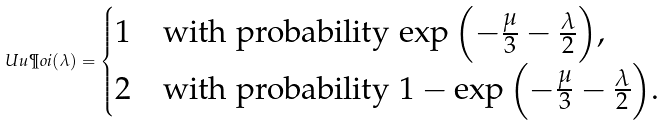<formula> <loc_0><loc_0><loc_500><loc_500>\ U u \P o i ( \lambda ) = \begin{cases} 1 & \text {with probability $\exp\left(-\frac{\mu}{3}-\frac{\lambda}{2}\right)$,} \\ 2 & \text {with probability $1-\exp\left(-\frac{\mu}{3}-\frac{\lambda}{2}\right)$.} \end{cases}</formula> 